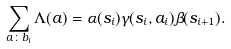<formula> <loc_0><loc_0><loc_500><loc_500>\sum _ { { a } \colon b _ { i } } \Lambda ( { a } ) = \alpha ( s _ { i } ) \gamma ( s _ { i } , { a } _ { i } ) \beta ( s _ { i + 1 } ) .</formula> 